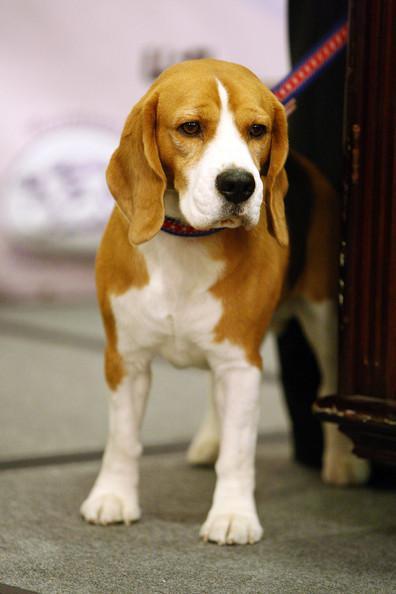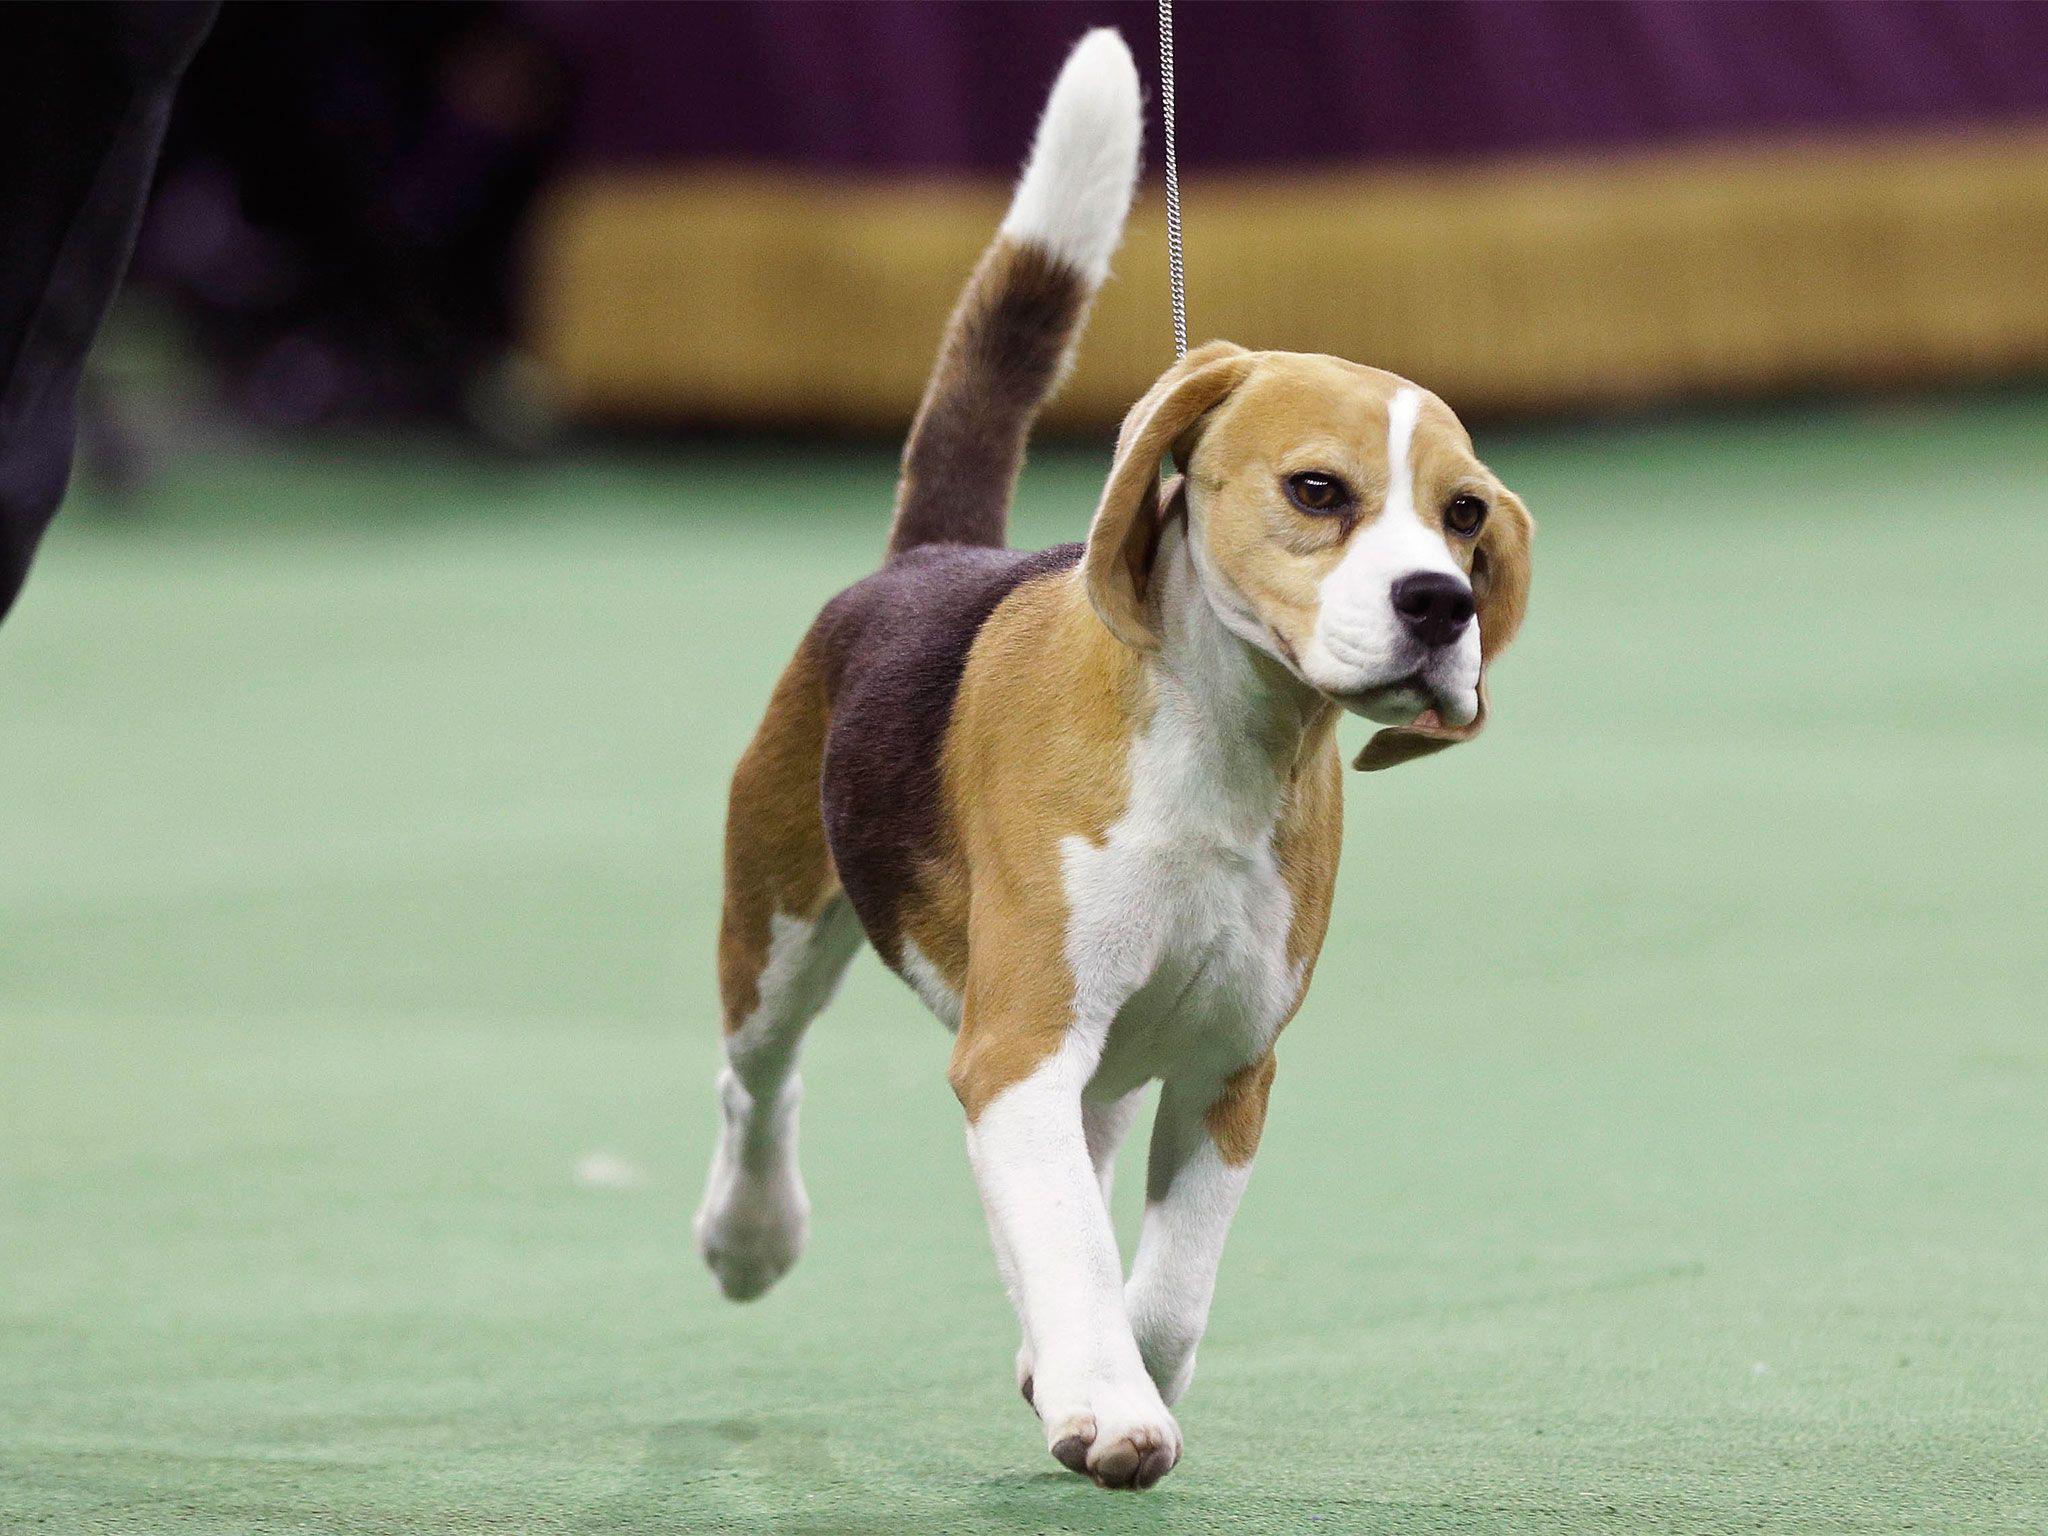The first image is the image on the left, the second image is the image on the right. Given the left and right images, does the statement "The dog in each image is on a leash." hold true? Answer yes or no. Yes. 